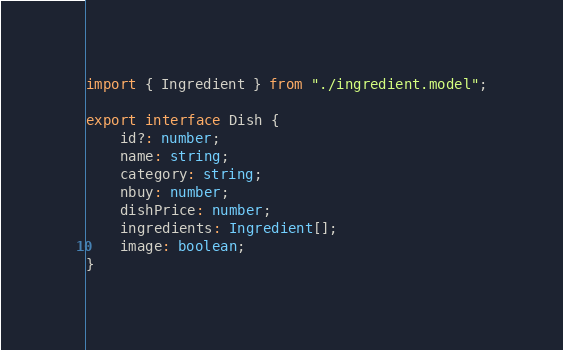Convert code to text. <code><loc_0><loc_0><loc_500><loc_500><_TypeScript_>import { Ingredient } from "./ingredient.model";

export interface Dish {
	id?: number;
	name: string;
	category: string;
	nbuy: number;
	dishPrice: number;
	ingredients: Ingredient[];
	image: boolean;
}
</code> 